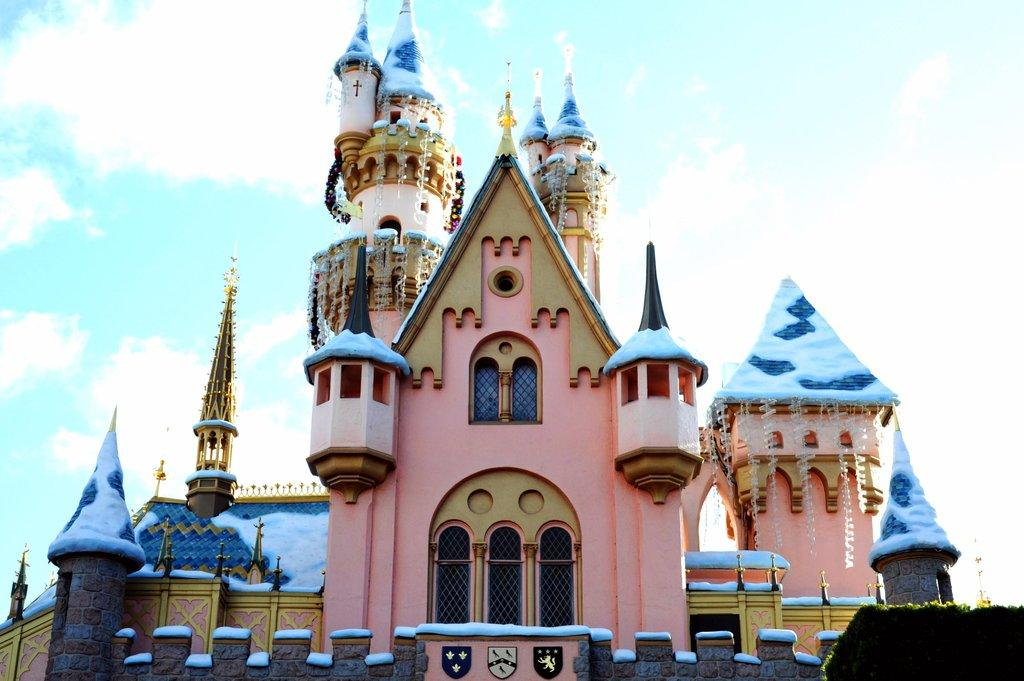What type of building is in the picture? There is a church in the picture. What features can be seen on the church? The church has doors and windows. What is visible at the top of the picture? The sky is visible at the top of the picture. What can be observed in the sky? Clouds are present in the sky. What team is responsible for the aftermath of the fly incident in the picture? There is no team, fly incident, or any reference to a fly in the picture. 